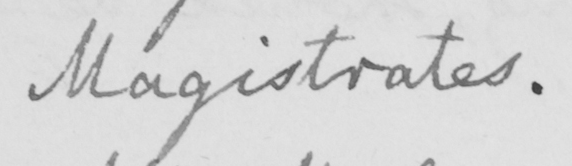What text is written in this handwritten line? Magistrates . 